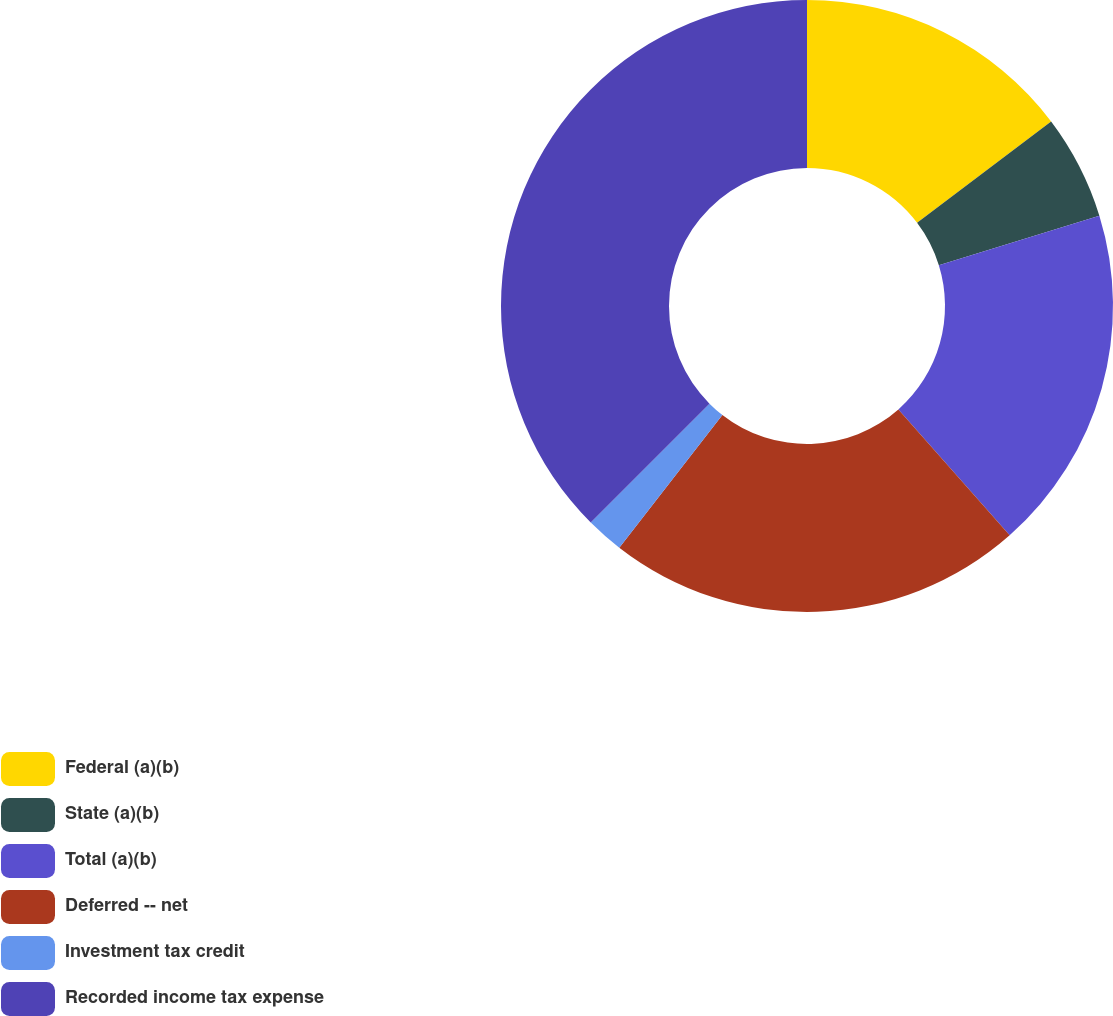Convert chart to OTSL. <chart><loc_0><loc_0><loc_500><loc_500><pie_chart><fcel>Federal (a)(b)<fcel>State (a)(b)<fcel>Total (a)(b)<fcel>Deferred -- net<fcel>Investment tax credit<fcel>Recorded income tax expense<nl><fcel>14.7%<fcel>5.53%<fcel>18.25%<fcel>22.03%<fcel>1.98%<fcel>37.51%<nl></chart> 